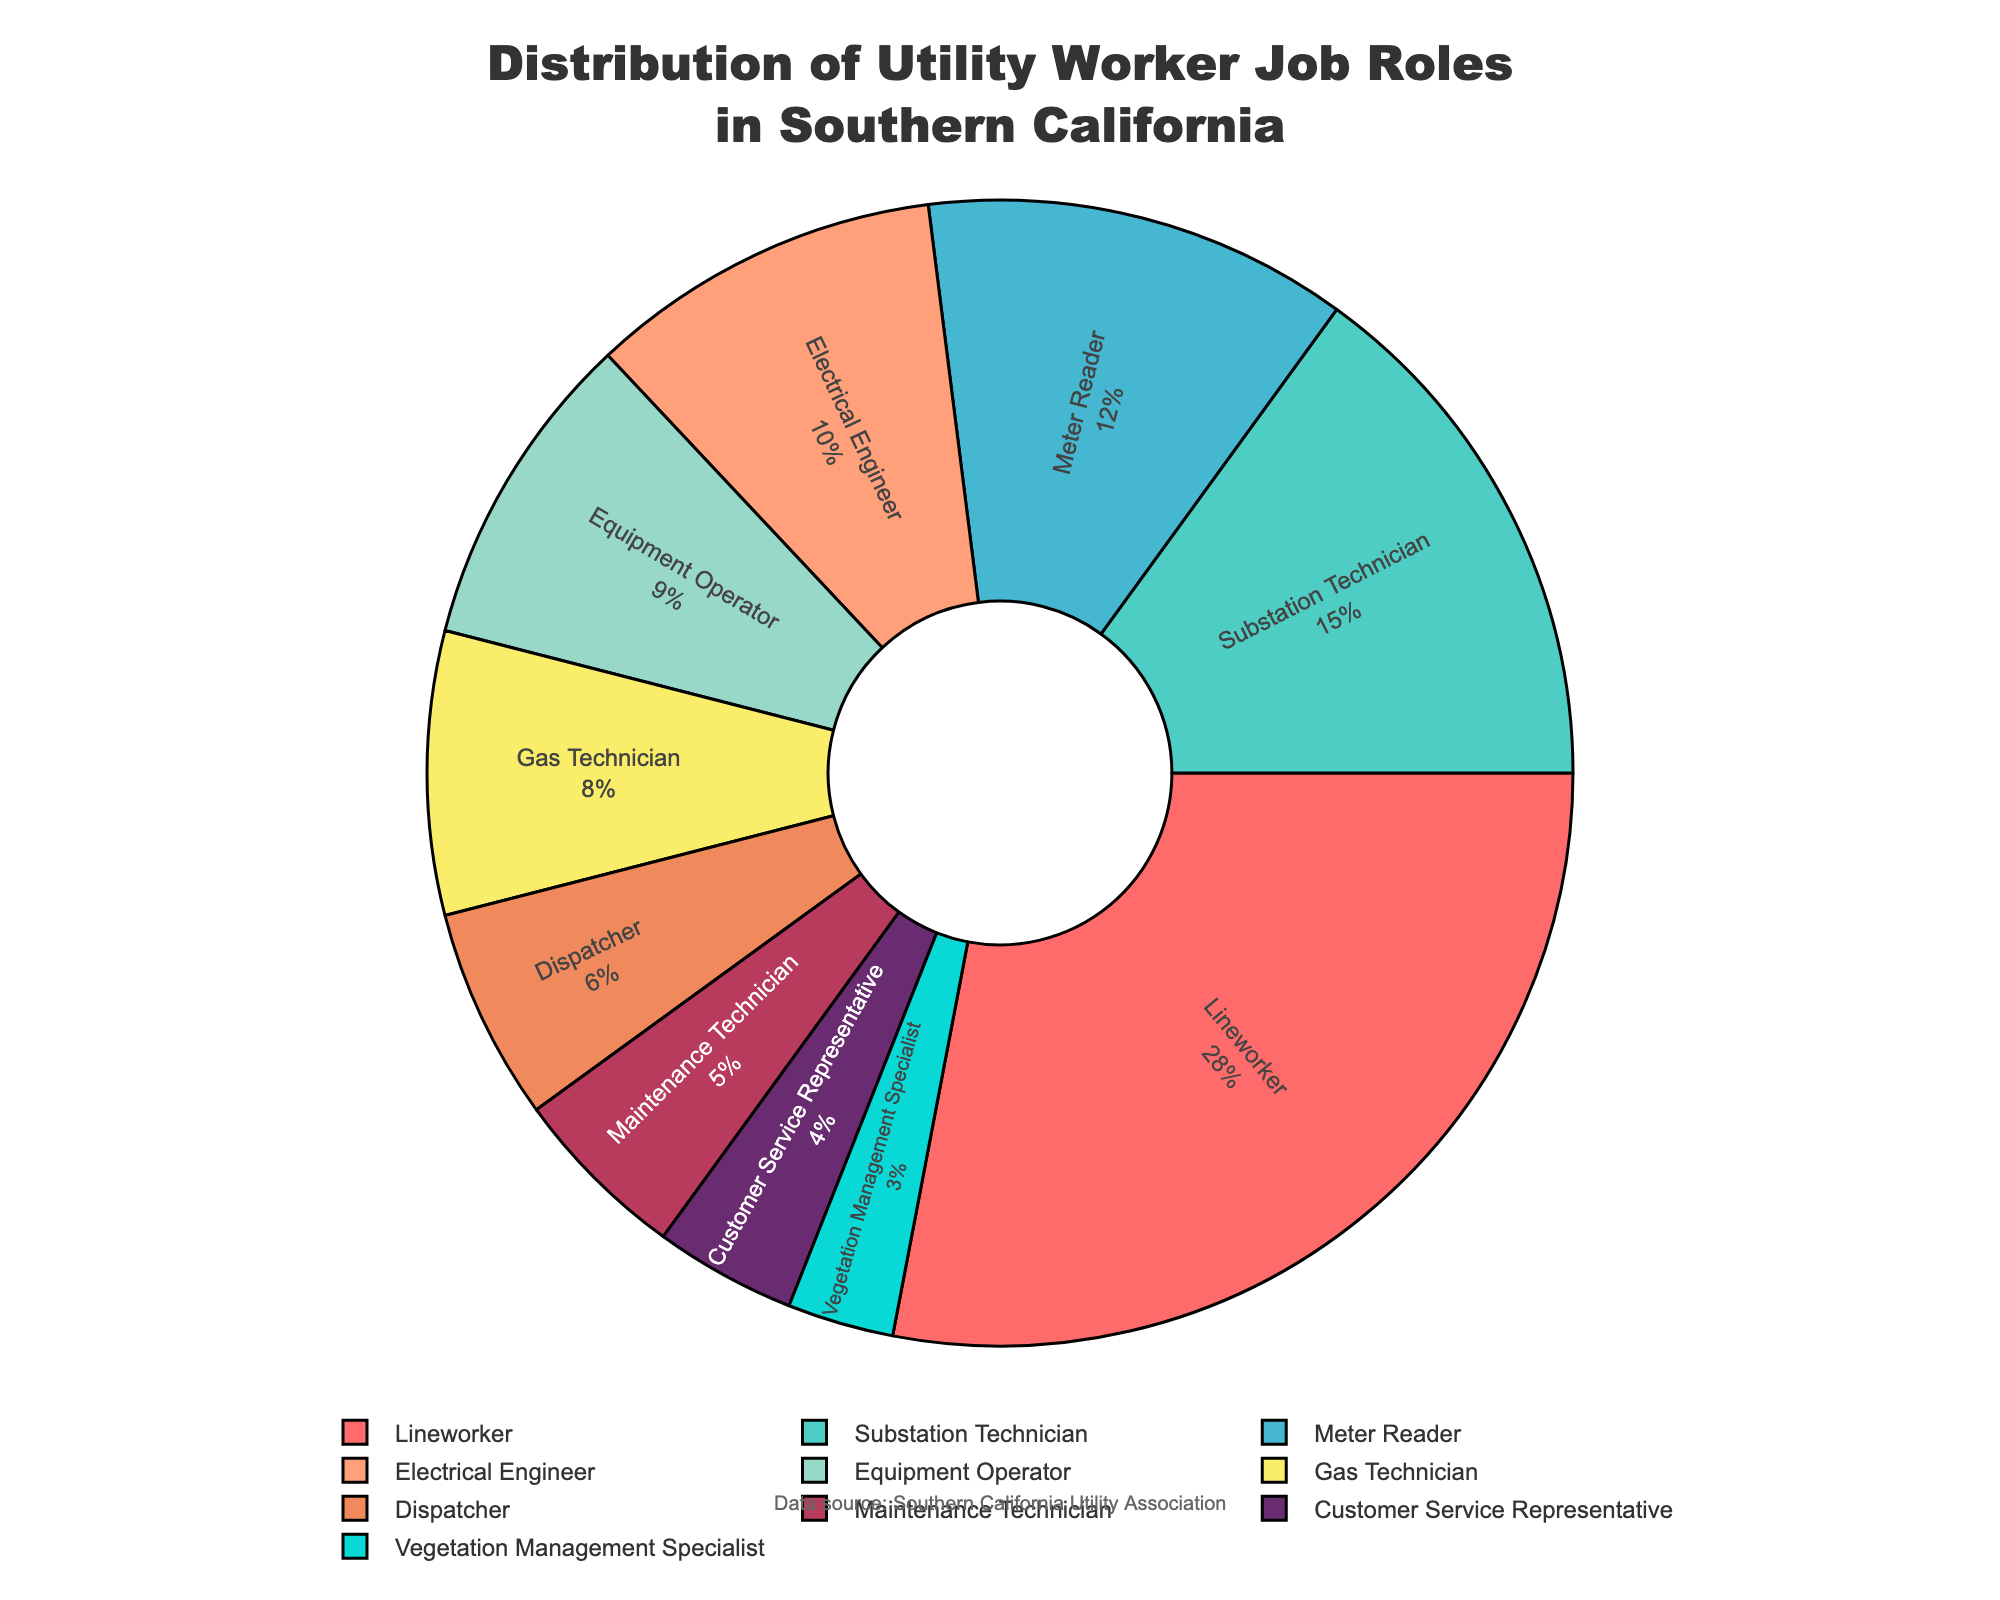What is the largest job role percentage in the pie chart? The largest percentage is the segment with the greatest size. In this case, the "Lineworker" segment accounts for 28% of the distribution, which is the largest.
Answer: Lineworker at 28% Which job role has a smaller percentage, "Meter Reader" or "Gas Technician"? Comparing the two percentages directly, "Meter Reader" has 12% while "Gas Technician" has 8%. Thus, "Gas Technician" has a smaller percentage.
Answer: Gas Technician at 8% What is the combined percentage of "Substation Technician" and "Electrical Engineer"? Add the percentages of "Substation Technician" (15%) and "Electrical Engineer" (10%). 15% + 10% = 25%.
Answer: 25% How does the percentage of "Customer Service Representative" compare to that of "Dispatcher"? "Customer Service Representative" is 4%, while "Dispatcher" is 6%. Therefore, "Customer Service Representative" has a smaller percentage than "Dispatcher".
Answer: 4% smaller Which job role comes after "Electrical Engineer" in terms of percentage? Look at the job roles by percentage: "Lineworker" (28%), "Substation Technician" (15%), "Meter Reader" (12%), "Electrical Engineer" (10%). The next is "Equipment Operator" at 9%.
Answer: Equipment Operator Which job roles are represented by the colors red and blue? The color red represents the "Lineworker" segment and blue represents the "Electrical Engineer" segment based on the provided color scheme.
Answer: Lineworker and Electrical Engineer How does the sum of the percentages for "Dispatcher" and "Gas Technician" compare to "Substation Technician"? Sum the percentages: "Dispatcher" (6%) + "Gas Technician" (8%) = 14%, which is less than "Substation Technician" at 15%.
Answer: 1% smaller What percent of the pie chart does not involve technical job roles (i.e., roles not involving equipment/technical operations)? Add percentages of non-technical roles: "Meter Reader" (12%), "Dispatcher" (6%), "Customer Service Representative" (4%), "Vegetation Management Specialist" (3%). 12% + 6% + 4% + 3% = 25%.
Answer: 25% How many job roles account for less than 10% each? Count the segments with percentages less than 10%: "Equipment Operator" (9%), "Gas Technician" (8%), "Dispatcher" (6%), "Maintenance Technician" (5%), "Customer Service Representative" (4%), "Vegetation Management Specialist" (3%). There are 6 such job roles.
Answer: 6 Is the sum of "Maintenance Technician" and "Vegetation Management Specialist" percentages smaller than "Lineworker"? Sum the percentages: "Maintenance Technician" (5%) + "Vegetation Management Specialist" (3%) = 8%, which is smaller than "Lineworker" at 28%.
Answer: Yes, 20% smaller 